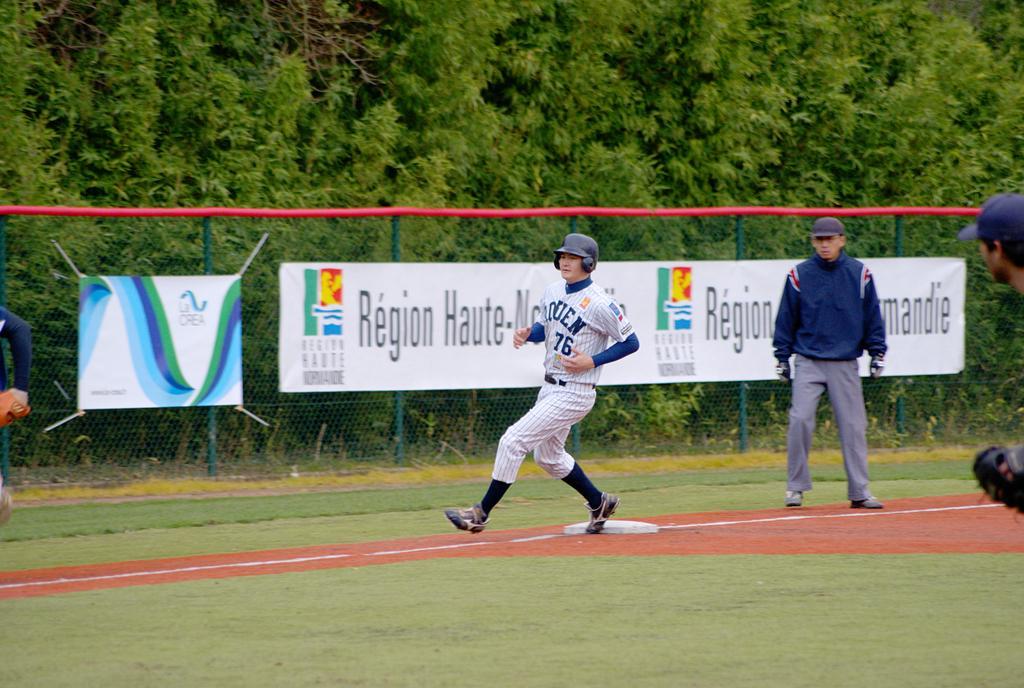In one or two sentences, can you explain what this image depicts? In this image there are persons standing and running. In the background there are banners with some text written on it and there is a fence and there are trees. 